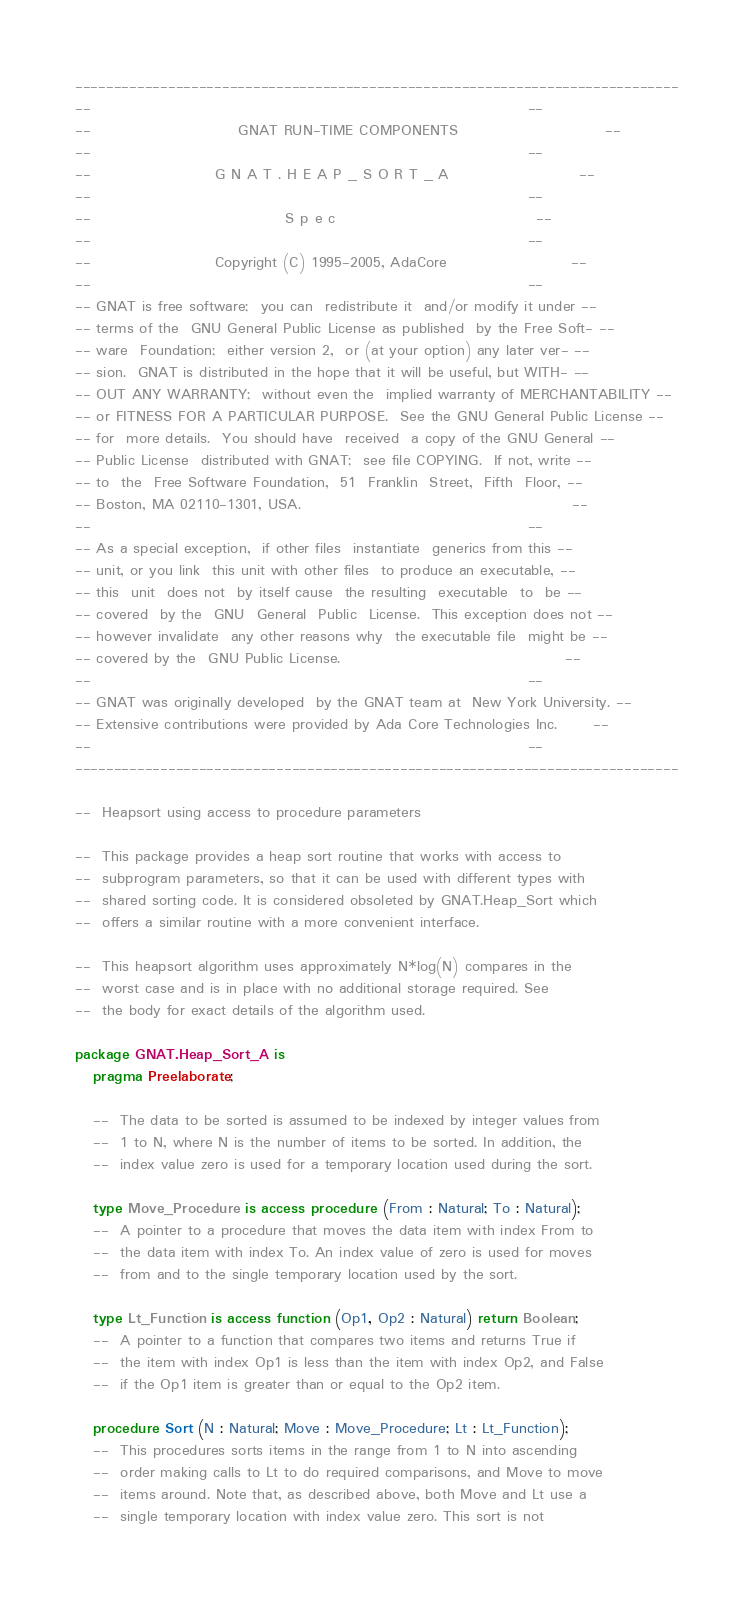<code> <loc_0><loc_0><loc_500><loc_500><_Ada_>------------------------------------------------------------------------------
--                                                                          --
--                         GNAT RUN-TIME COMPONENTS                         --
--                                                                          --
--                     G N A T . H E A P _ S O R T _ A                      --
--                                                                          --
--                                 S p e c                                  --
--                                                                          --
--                     Copyright (C) 1995-2005, AdaCore                     --
--                                                                          --
-- GNAT is free software;  you can  redistribute it  and/or modify it under --
-- terms of the  GNU General Public License as published  by the Free Soft- --
-- ware  Foundation;  either version 2,  or (at your option) any later ver- --
-- sion.  GNAT is distributed in the hope that it will be useful, but WITH- --
-- OUT ANY WARRANTY;  without even the  implied warranty of MERCHANTABILITY --
-- or FITNESS FOR A PARTICULAR PURPOSE.  See the GNU General Public License --
-- for  more details.  You should have  received  a copy of the GNU General --
-- Public License  distributed with GNAT;  see file COPYING.  If not, write --
-- to  the  Free Software Foundation,  51  Franklin  Street,  Fifth  Floor, --
-- Boston, MA 02110-1301, USA.                                              --
--                                                                          --
-- As a special exception,  if other files  instantiate  generics from this --
-- unit, or you link  this unit with other files  to produce an executable, --
-- this  unit  does not  by itself cause  the resulting  executable  to  be --
-- covered  by the  GNU  General  Public  License.  This exception does not --
-- however invalidate  any other reasons why  the executable file  might be --
-- covered by the  GNU Public License.                                      --
--                                                                          --
-- GNAT was originally developed  by the GNAT team at  New York University. --
-- Extensive contributions were provided by Ada Core Technologies Inc.      --
--                                                                          --
------------------------------------------------------------------------------

--  Heapsort using access to procedure parameters

--  This package provides a heap sort routine that works with access to
--  subprogram parameters, so that it can be used with different types with
--  shared sorting code. It is considered obsoleted by GNAT.Heap_Sort which
--  offers a similar routine with a more convenient interface.

--  This heapsort algorithm uses approximately N*log(N) compares in the
--  worst case and is in place with no additional storage required. See
--  the body for exact details of the algorithm used.

package GNAT.Heap_Sort_A is
   pragma Preelaborate;

   --  The data to be sorted is assumed to be indexed by integer values from
   --  1 to N, where N is the number of items to be sorted. In addition, the
   --  index value zero is used for a temporary location used during the sort.

   type Move_Procedure is access procedure (From : Natural; To : Natural);
   --  A pointer to a procedure that moves the data item with index From to
   --  the data item with index To. An index value of zero is used for moves
   --  from and to the single temporary location used by the sort.

   type Lt_Function is access function (Op1, Op2 : Natural) return Boolean;
   --  A pointer to a function that compares two items and returns True if
   --  the item with index Op1 is less than the item with index Op2, and False
   --  if the Op1 item is greater than or equal to the Op2 item.

   procedure Sort (N : Natural; Move : Move_Procedure; Lt : Lt_Function);
   --  This procedures sorts items in the range from 1 to N into ascending
   --  order making calls to Lt to do required comparisons, and Move to move
   --  items around. Note that, as described above, both Move and Lt use a
   --  single temporary location with index value zero. This sort is not</code> 